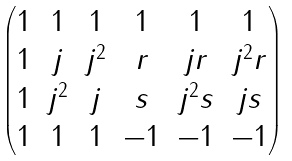<formula> <loc_0><loc_0><loc_500><loc_500>\begin{pmatrix} 1 & 1 & 1 & 1 & 1 & 1 \\ 1 & j & j ^ { 2 } & r & j r & j ^ { 2 } r \\ 1 & j ^ { 2 } & j & s & j ^ { 2 } s & j s \\ 1 & 1 & 1 & - 1 & - 1 & - 1 \end{pmatrix}</formula> 